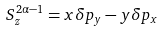<formula> <loc_0><loc_0><loc_500><loc_500>S ^ { 2 \alpha - 1 } _ { z } = x \delta p _ { y } - y \delta p _ { x }</formula> 